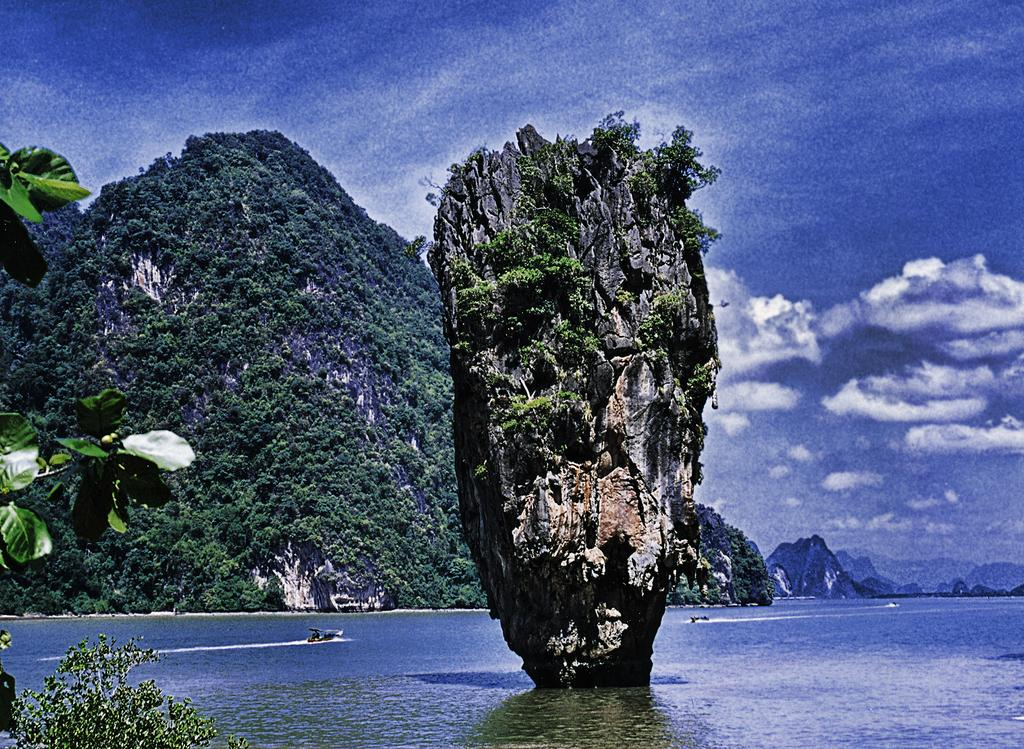What type of natural feature is present in the image? There is a river in the image. What other geographical features can be seen in the image? There are hills and trees in the image. How is the hill positioned in relation to the river? One hill is in the middle of the river. Where is the honey located in the image? There is no honey present in the image. Is there a tent visible in the image? There is no tent present in the image. 